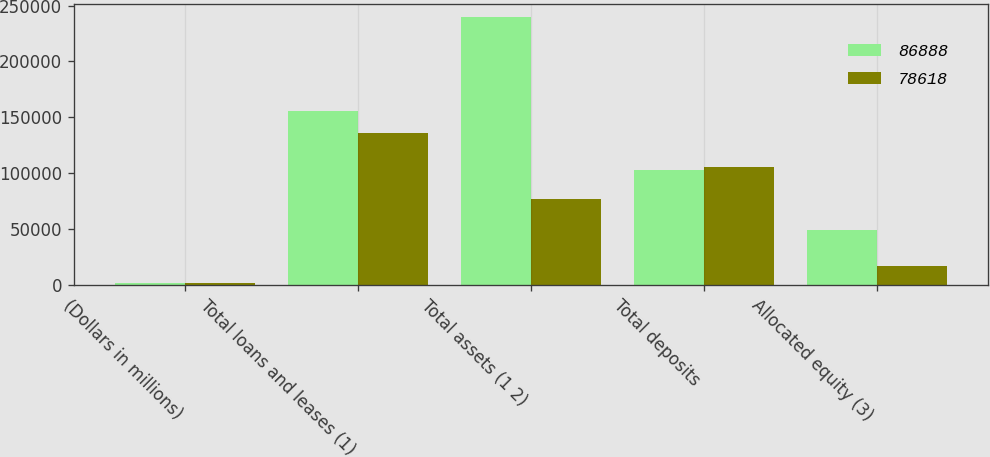Convert chart to OTSL. <chart><loc_0><loc_0><loc_500><loc_500><stacked_bar_chart><ecel><fcel>(Dollars in millions)<fcel>Total loans and leases (1)<fcel>Total assets (1 2)<fcel>Total deposits<fcel>Allocated equity (3)<nl><fcel>86888<fcel>2009<fcel>155561<fcel>239642<fcel>103122<fcel>49015<nl><fcel>78618<fcel>2008<fcel>135789<fcel>77244<fcel>105725<fcel>16563<nl></chart> 